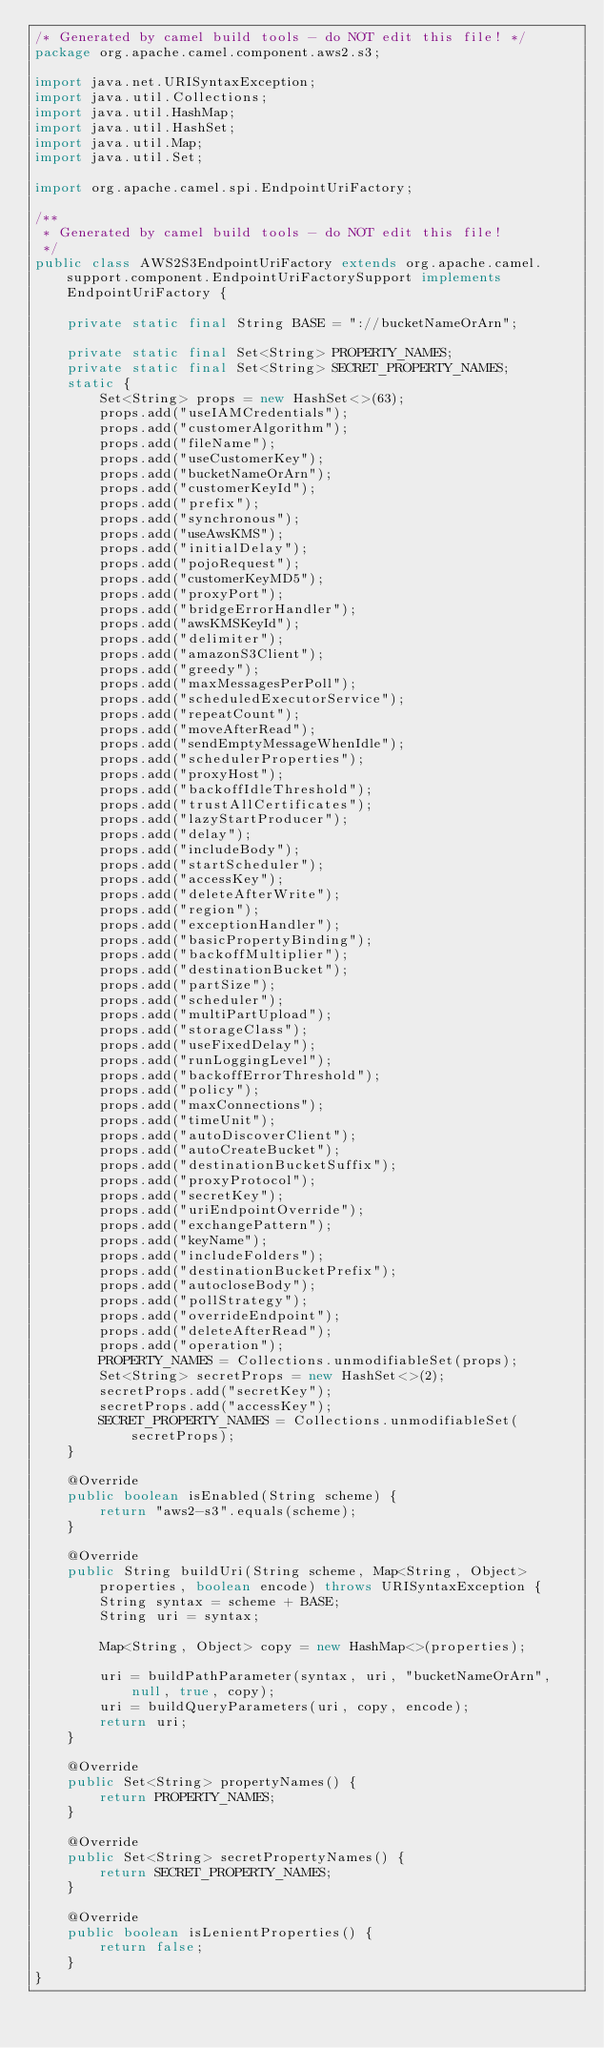<code> <loc_0><loc_0><loc_500><loc_500><_Java_>/* Generated by camel build tools - do NOT edit this file! */
package org.apache.camel.component.aws2.s3;

import java.net.URISyntaxException;
import java.util.Collections;
import java.util.HashMap;
import java.util.HashSet;
import java.util.Map;
import java.util.Set;

import org.apache.camel.spi.EndpointUriFactory;

/**
 * Generated by camel build tools - do NOT edit this file!
 */
public class AWS2S3EndpointUriFactory extends org.apache.camel.support.component.EndpointUriFactorySupport implements EndpointUriFactory {

    private static final String BASE = "://bucketNameOrArn";

    private static final Set<String> PROPERTY_NAMES;
    private static final Set<String> SECRET_PROPERTY_NAMES;
    static {
        Set<String> props = new HashSet<>(63);
        props.add("useIAMCredentials");
        props.add("customerAlgorithm");
        props.add("fileName");
        props.add("useCustomerKey");
        props.add("bucketNameOrArn");
        props.add("customerKeyId");
        props.add("prefix");
        props.add("synchronous");
        props.add("useAwsKMS");
        props.add("initialDelay");
        props.add("pojoRequest");
        props.add("customerKeyMD5");
        props.add("proxyPort");
        props.add("bridgeErrorHandler");
        props.add("awsKMSKeyId");
        props.add("delimiter");
        props.add("amazonS3Client");
        props.add("greedy");
        props.add("maxMessagesPerPoll");
        props.add("scheduledExecutorService");
        props.add("repeatCount");
        props.add("moveAfterRead");
        props.add("sendEmptyMessageWhenIdle");
        props.add("schedulerProperties");
        props.add("proxyHost");
        props.add("backoffIdleThreshold");
        props.add("trustAllCertificates");
        props.add("lazyStartProducer");
        props.add("delay");
        props.add("includeBody");
        props.add("startScheduler");
        props.add("accessKey");
        props.add("deleteAfterWrite");
        props.add("region");
        props.add("exceptionHandler");
        props.add("basicPropertyBinding");
        props.add("backoffMultiplier");
        props.add("destinationBucket");
        props.add("partSize");
        props.add("scheduler");
        props.add("multiPartUpload");
        props.add("storageClass");
        props.add("useFixedDelay");
        props.add("runLoggingLevel");
        props.add("backoffErrorThreshold");
        props.add("policy");
        props.add("maxConnections");
        props.add("timeUnit");
        props.add("autoDiscoverClient");
        props.add("autoCreateBucket");
        props.add("destinationBucketSuffix");
        props.add("proxyProtocol");
        props.add("secretKey");
        props.add("uriEndpointOverride");
        props.add("exchangePattern");
        props.add("keyName");
        props.add("includeFolders");
        props.add("destinationBucketPrefix");
        props.add("autocloseBody");
        props.add("pollStrategy");
        props.add("overrideEndpoint");
        props.add("deleteAfterRead");
        props.add("operation");
        PROPERTY_NAMES = Collections.unmodifiableSet(props);
        Set<String> secretProps = new HashSet<>(2);
        secretProps.add("secretKey");
        secretProps.add("accessKey");
        SECRET_PROPERTY_NAMES = Collections.unmodifiableSet(secretProps);
    }

    @Override
    public boolean isEnabled(String scheme) {
        return "aws2-s3".equals(scheme);
    }

    @Override
    public String buildUri(String scheme, Map<String, Object> properties, boolean encode) throws URISyntaxException {
        String syntax = scheme + BASE;
        String uri = syntax;

        Map<String, Object> copy = new HashMap<>(properties);

        uri = buildPathParameter(syntax, uri, "bucketNameOrArn", null, true, copy);
        uri = buildQueryParameters(uri, copy, encode);
        return uri;
    }

    @Override
    public Set<String> propertyNames() {
        return PROPERTY_NAMES;
    }

    @Override
    public Set<String> secretPropertyNames() {
        return SECRET_PROPERTY_NAMES;
    }

    @Override
    public boolean isLenientProperties() {
        return false;
    }
}

</code> 